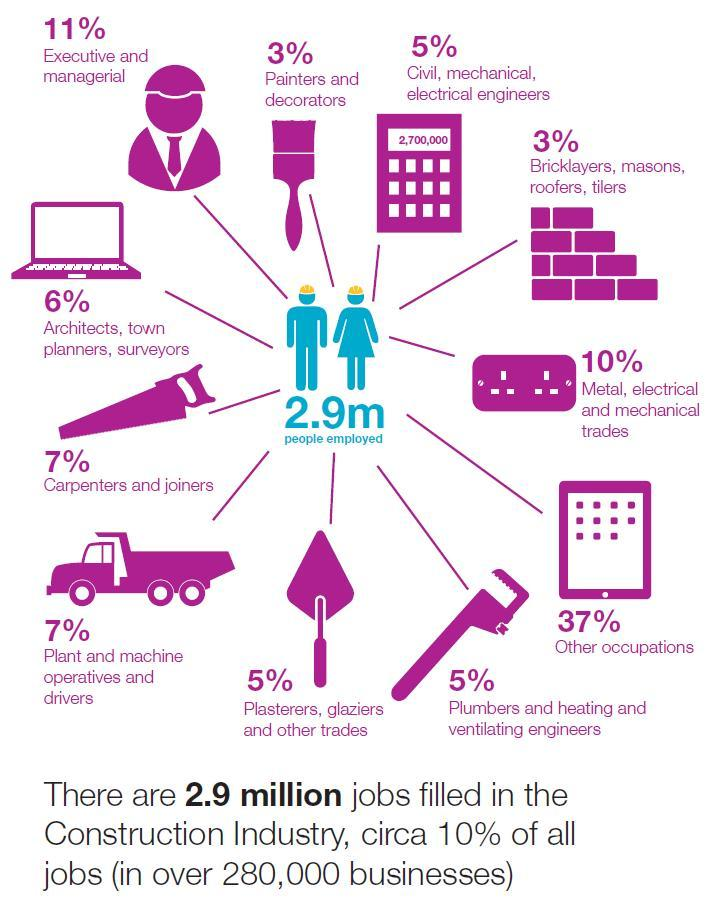What % dont have their occupation defined
Answer the question with a short phrase. 37% What percent of the people employed are plant & machine operatives & drivers? 7% What percent of the people employed are painters & decorators? 3% Which category of people have the same percentage as plant and machine operatives and drivers Carpenters and joiners What percent of the people employed are architects, town planners & surveyors? 6% What category does the saw indicate Carpenters and joiners How many people are employed 2.9m 